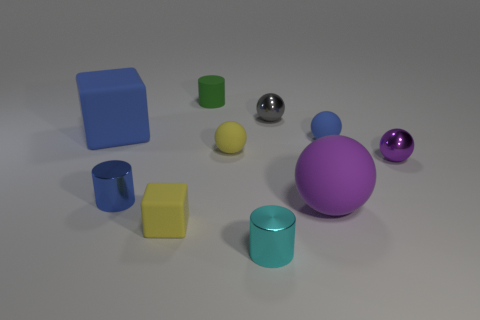Subtract all brown cylinders. How many purple balls are left? 2 Subtract 2 balls. How many balls are left? 3 Subtract all blue balls. How many balls are left? 4 Subtract all big purple spheres. How many spheres are left? 4 Subtract all yellow spheres. Subtract all cyan blocks. How many spheres are left? 4 Subtract all cubes. How many objects are left? 8 Add 7 gray spheres. How many gray spheres are left? 8 Add 3 tiny purple things. How many tiny purple things exist? 4 Subtract 0 gray blocks. How many objects are left? 10 Subtract all tiny green rubber objects. Subtract all tiny balls. How many objects are left? 5 